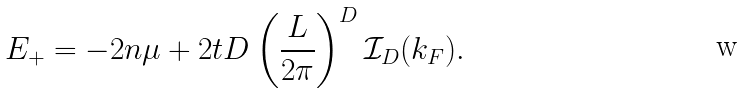<formula> <loc_0><loc_0><loc_500><loc_500>E _ { + } = - 2 n \mu + 2 t D \left ( \frac { L } { 2 \pi } \right ) ^ { D } \mathcal { I } _ { D } ( k _ { F } ) .</formula> 